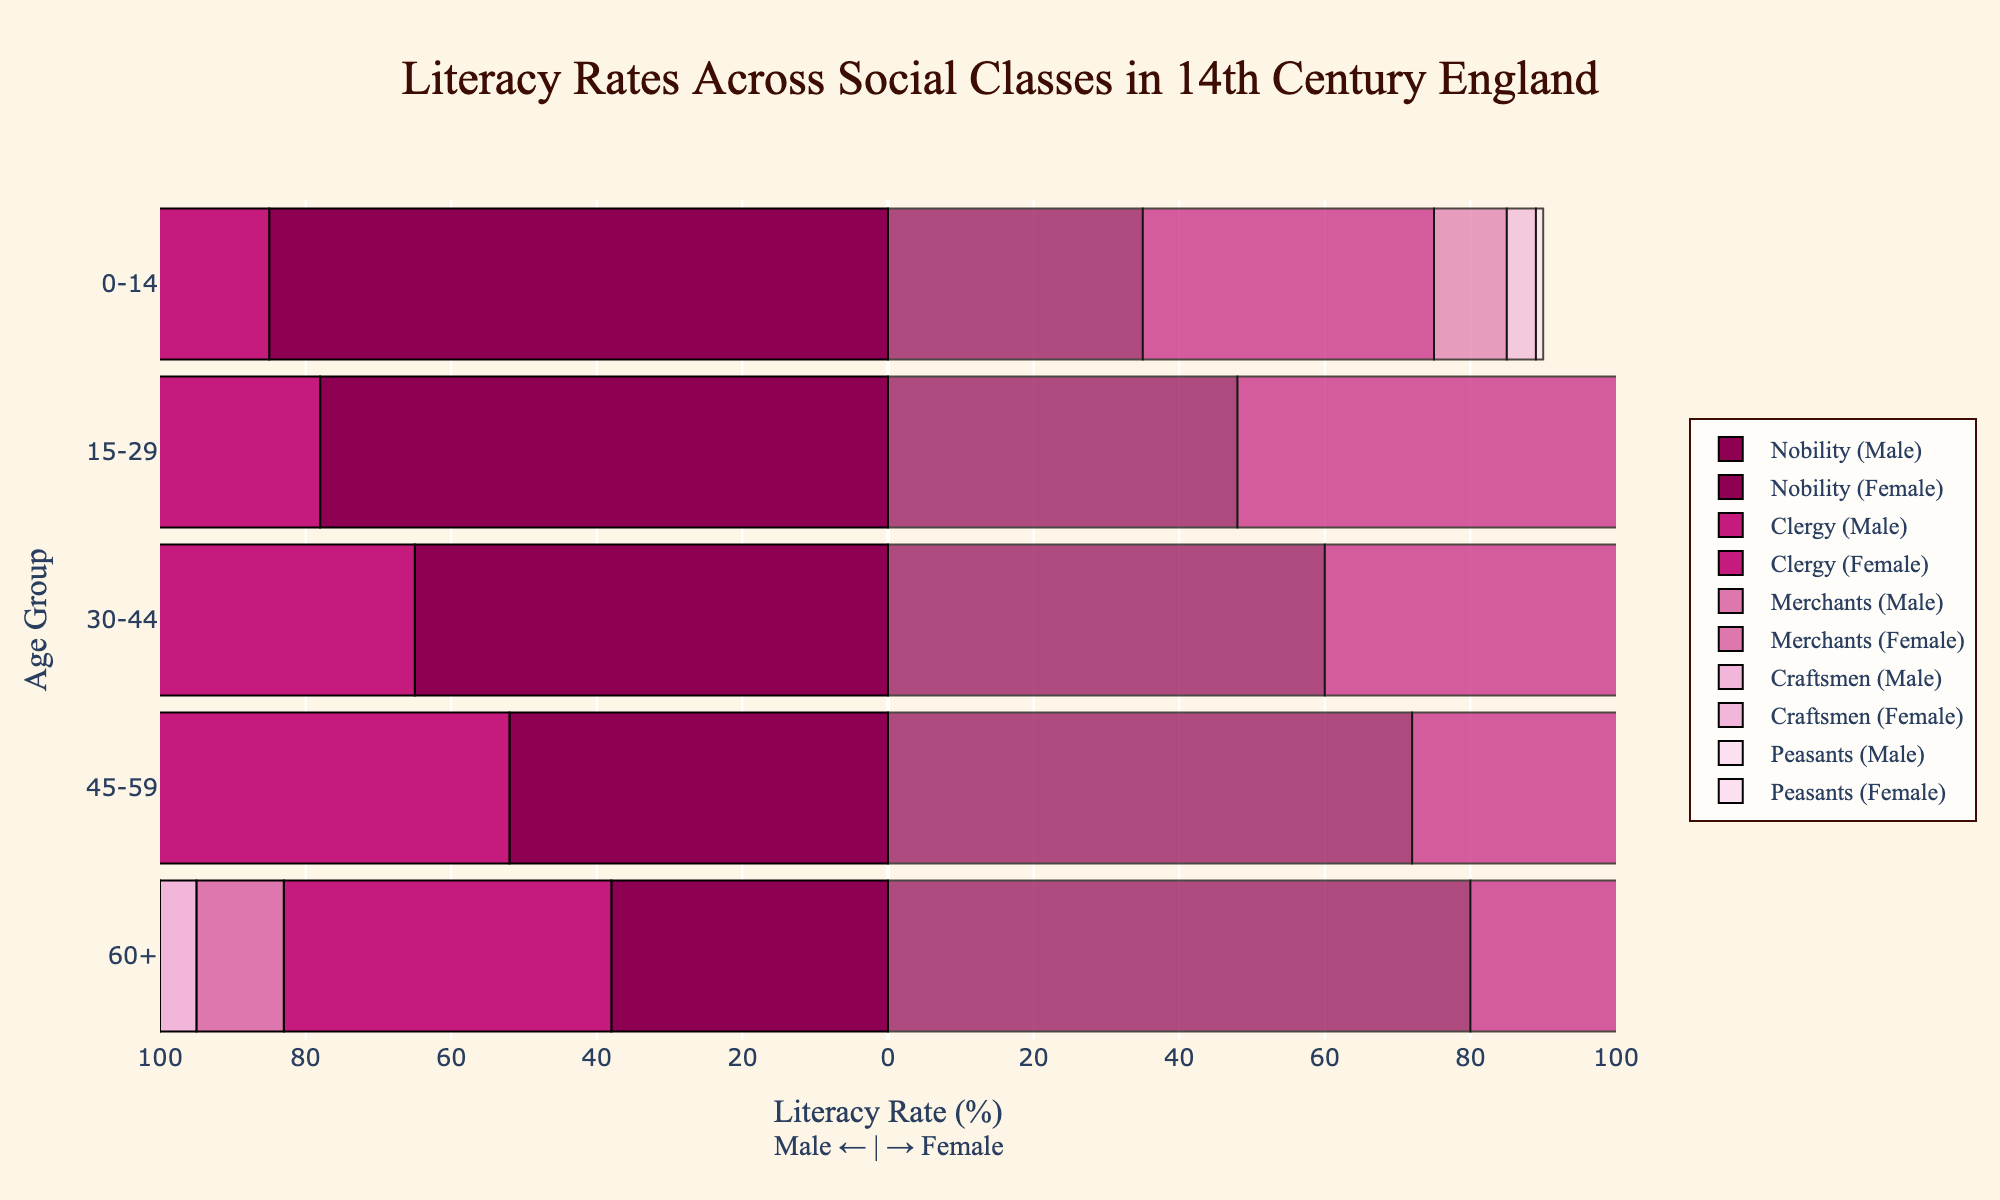Which age group has the highest literacy rate among male nobles? Looking at the male nobles section (left side of the bars), the age group 0-14 has the longest bar, representing the highest literacy rate
Answer: 0-14 What is the difference in literacy rate between male clergy and female clergy in the age group 30-44? For the age group 30-44, the literacy rate for male clergy is 70, and for female clergy, it is 75. The difference can be calculated as 75 - 70 = 5
Answer: 5 Who has a higher literacy rate in the 15-29 age group, male merchants or male craftsmen? By examining the figure, the length of the bar for male merchants in the 15-29 age group is longer than that of the male craftsmen
Answer: Male merchants Among the peasants, which age group shows the least literacy rate for females? Observing the female peasants' section (right side of the bars), the 60+ age group has the shortest bar, indicating the least literacy rate
Answer: 60+ What is the average literacy rate for female merchants across all age groups? Female merchants' rates are 20, 22, 25, 18, and 15. Summing them up: 20 + 22 + 25 + 18 + 15 = 100. Then, the average is 100 / 5 = 20
Answer: 20 Compare the literacy rates of male and female craftsmen in the 45-59 age group. Who has a higher literacy rate and by how much? The literacy rate for male craftsmen in 45-59 is 6 and for females, it is 8. The difference is 8 - 6 = 2 and females have a higher rate
Answer: Females, by 2 What is the trend of literacy rates among female clergy as age increases? Starting from 0-14 up to 60+, literacy rates for female clergy decrease: 90, 85, 75, 60, 45. This indicates a declining trend
Answer: Decline How does the literacy rate of female peasants in the 0-14 age group compare to female merchants in the same group? The literacy rate for female peasants in 0-14 is 7, whereas for female merchants, it is 22. Female merchants have a significantly higher literacy rate
Answer: Female merchants have a higher rate Which social class exhibits the greatest difference in literacy rates between males and females in the age group 0-14? Comparing differences: Nobility (85 - 80 = 5), Clergy (90 - 88 = 2), Merchants (40 - 38 = 2), Craftsmen (22 - 20 = 2), Peasants (7 - 6 = 1). Nobility has the greatest difference
Answer: Nobility What is the total literacy rate of all male social classes in the age group 30-44? Summing all literacy rates for males in 30-44: Nobility (60), Clergy (70), Merchants (22), Craftsmen (10), Peasants (2). Total = 60 + 70 + 22 + 10 + 2 = 164
Answer: 164 